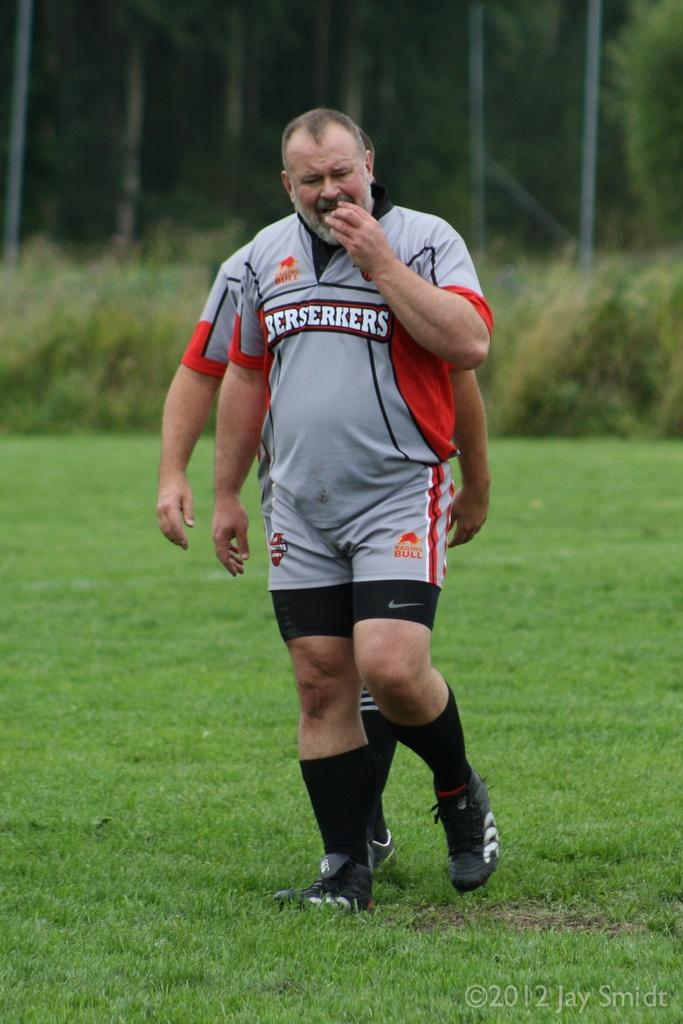How many people are in the image? There are two persons in the image. What are the persons doing in the image? The persons are walking on the ground. What can be seen in the background of the image? There are trees and grass in the background of the image. What type of prison can be seen in the image? There is no prison present in the image. Can you describe the stranger in the image? There are no strangers mentioned in the image; only two persons are described. 